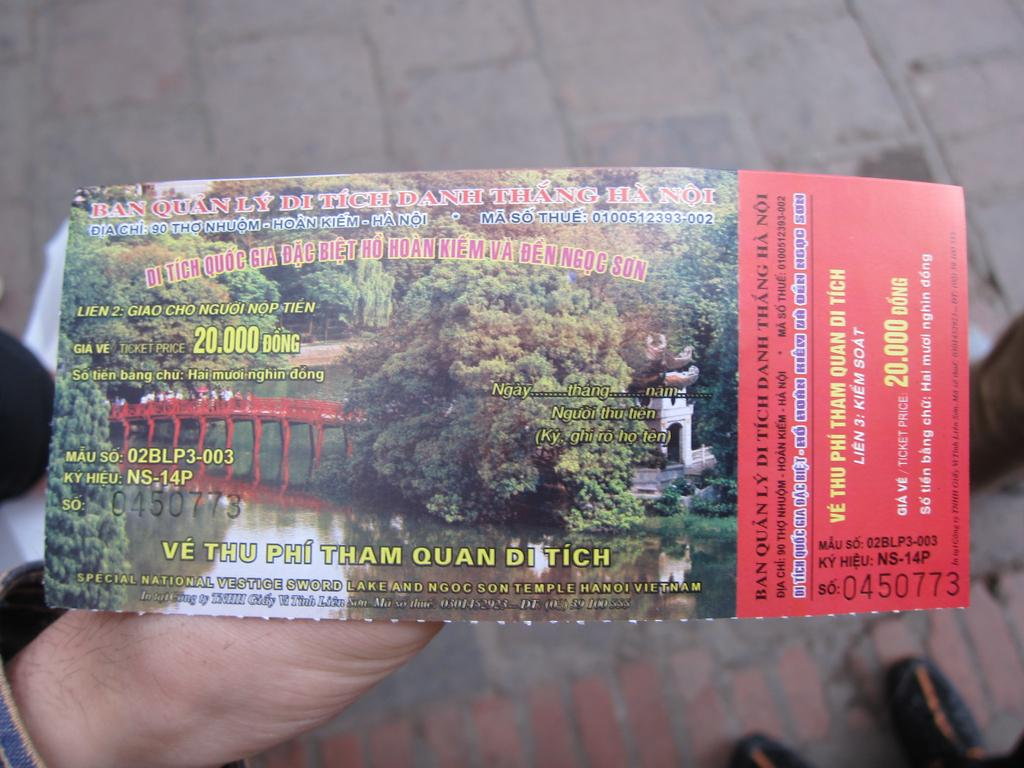Provide a one-sentence caption for the provided image. Ve Thu Phi Tham Quan Ditich will be seen by ticket holder 0450773. 